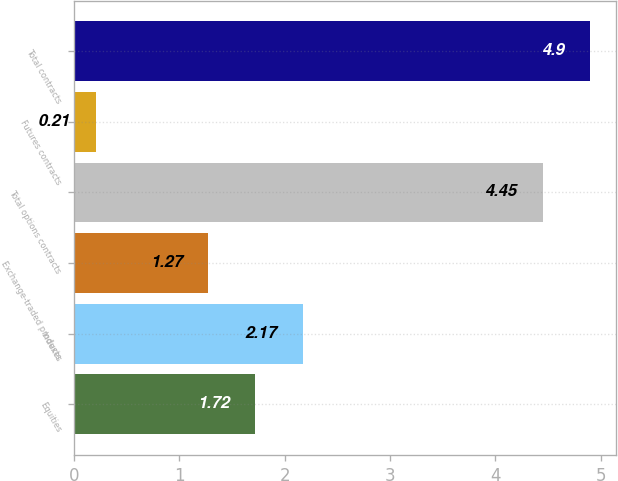Convert chart to OTSL. <chart><loc_0><loc_0><loc_500><loc_500><bar_chart><fcel>Equities<fcel>Indexes<fcel>Exchange-traded products<fcel>Total options contracts<fcel>Futures contracts<fcel>Total contracts<nl><fcel>1.72<fcel>2.17<fcel>1.27<fcel>4.45<fcel>0.21<fcel>4.9<nl></chart> 